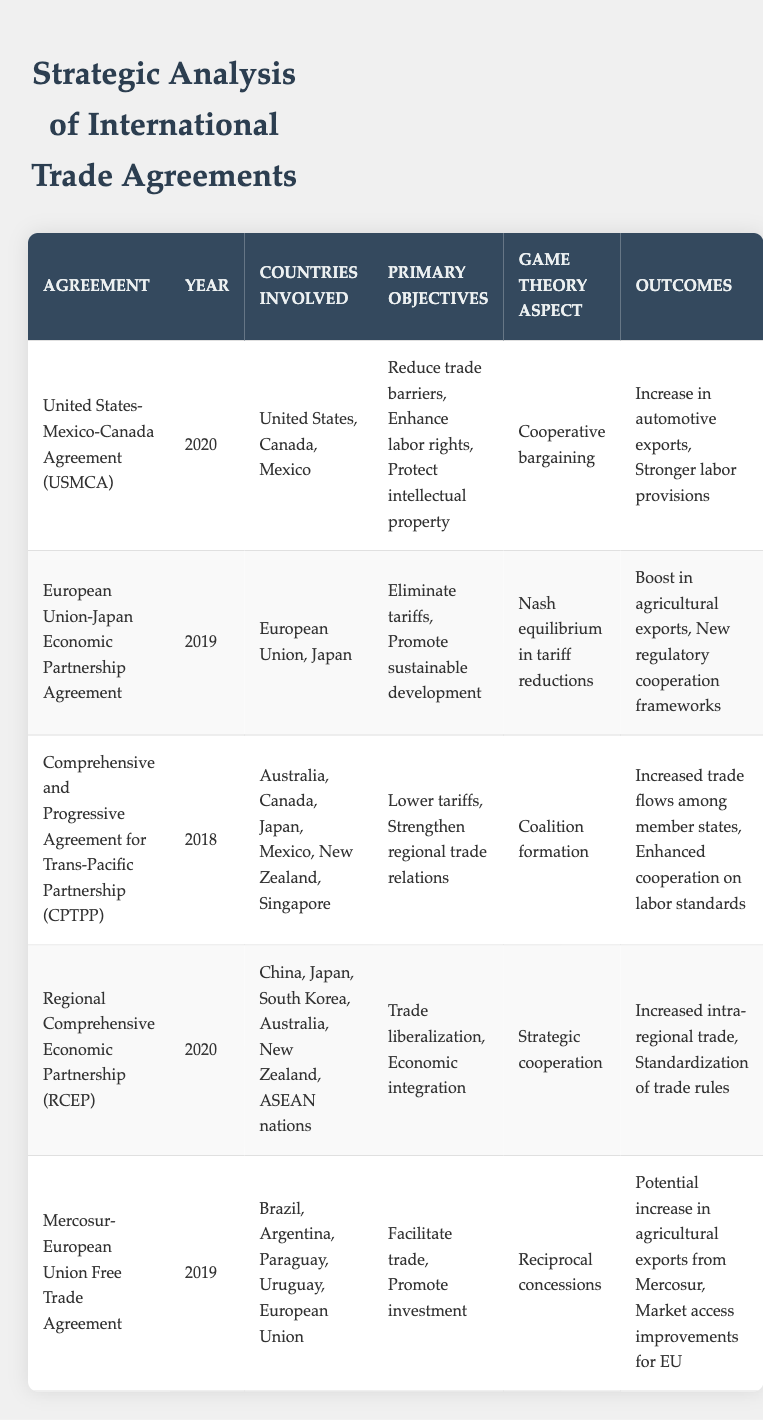What is the year of the United States-Mexico-Canada Agreement (USMCA)? The year for the USMCA agreement is listed directly in the table under the "Year" column for that specific agreement.
Answer: 2020 Which countries were involved in the Comprehensive and Progressive Agreement for Trans-Pacific Partnership (CPTPP)? The table provides a "Countries Involved" column where you can directly find the countries associated with CPTPP.
Answer: Australia, Canada, Japan, Mexico, New Zealand, Singapore How many agreements in the table focus on reducing trade barriers? By reviewing all the agreements in the table, we assess which primary objectives include "reduce trade barriers." The agreements that mention this are USMCA and CPTPP. Therefore, there are 2 that focus on this objective.
Answer: 2 Did the European Union-Japan Economic Partnership Agreement promote sustainable development? This can be answered by checking the "Primary Objectives" for the EU-Japan agreement; it specifically lists "Promote sustainable development." Thus, the statement is true.
Answer: Yes Which agreement resulted in an increase in agricultural exports from Mercosur? The "Outcomes" column for the Mercosur-European Union Free Trade Agreement indicates a potential increase in agricultural exports from Mercosur, confirming that this agreement is the one that resulted in this outcome.
Answer: Mercosur-European Union Free Trade Agreement What is the game theory aspect associated with the Regional Comprehensive Economic Partnership (RCEP)? By looking at the "Game Theory Aspect" column, RCEP has "Strategic cooperation" mentioned, which identifies the type of game theory aspect it utilized.
Answer: Strategic cooperation Which agreement had the objective of enhancing labor rights? The table lists the primary objectives for each agreement. Upon checking the USMCA entry, it indicates that one of its primary objectives is to enhance labor rights.
Answer: United States-Mexico-Canada Agreement (USMCA) How many agreements resulted in increased intra-regional trade? The table indicates that both the Regional Comprehensive Economic Partnership (RCEP) and the Comprehensive and Progressive Agreement for Trans-Pacific Partnership (CPTPP) show outcomes related to increased trade. Thus, there are two agreements with this outcome.
Answer: 2 What are the outcomes of the European Union-Japan Economic Partnership Agreement? By checking the "Outcomes" column of the EU-Japan agreement entry, the outcomes listed are "Boost in agricultural exports" and "New regulatory cooperation frameworks." Combining these results provides a complete answer.
Answer: Boost in agricultural exports, New regulatory cooperation frameworks 